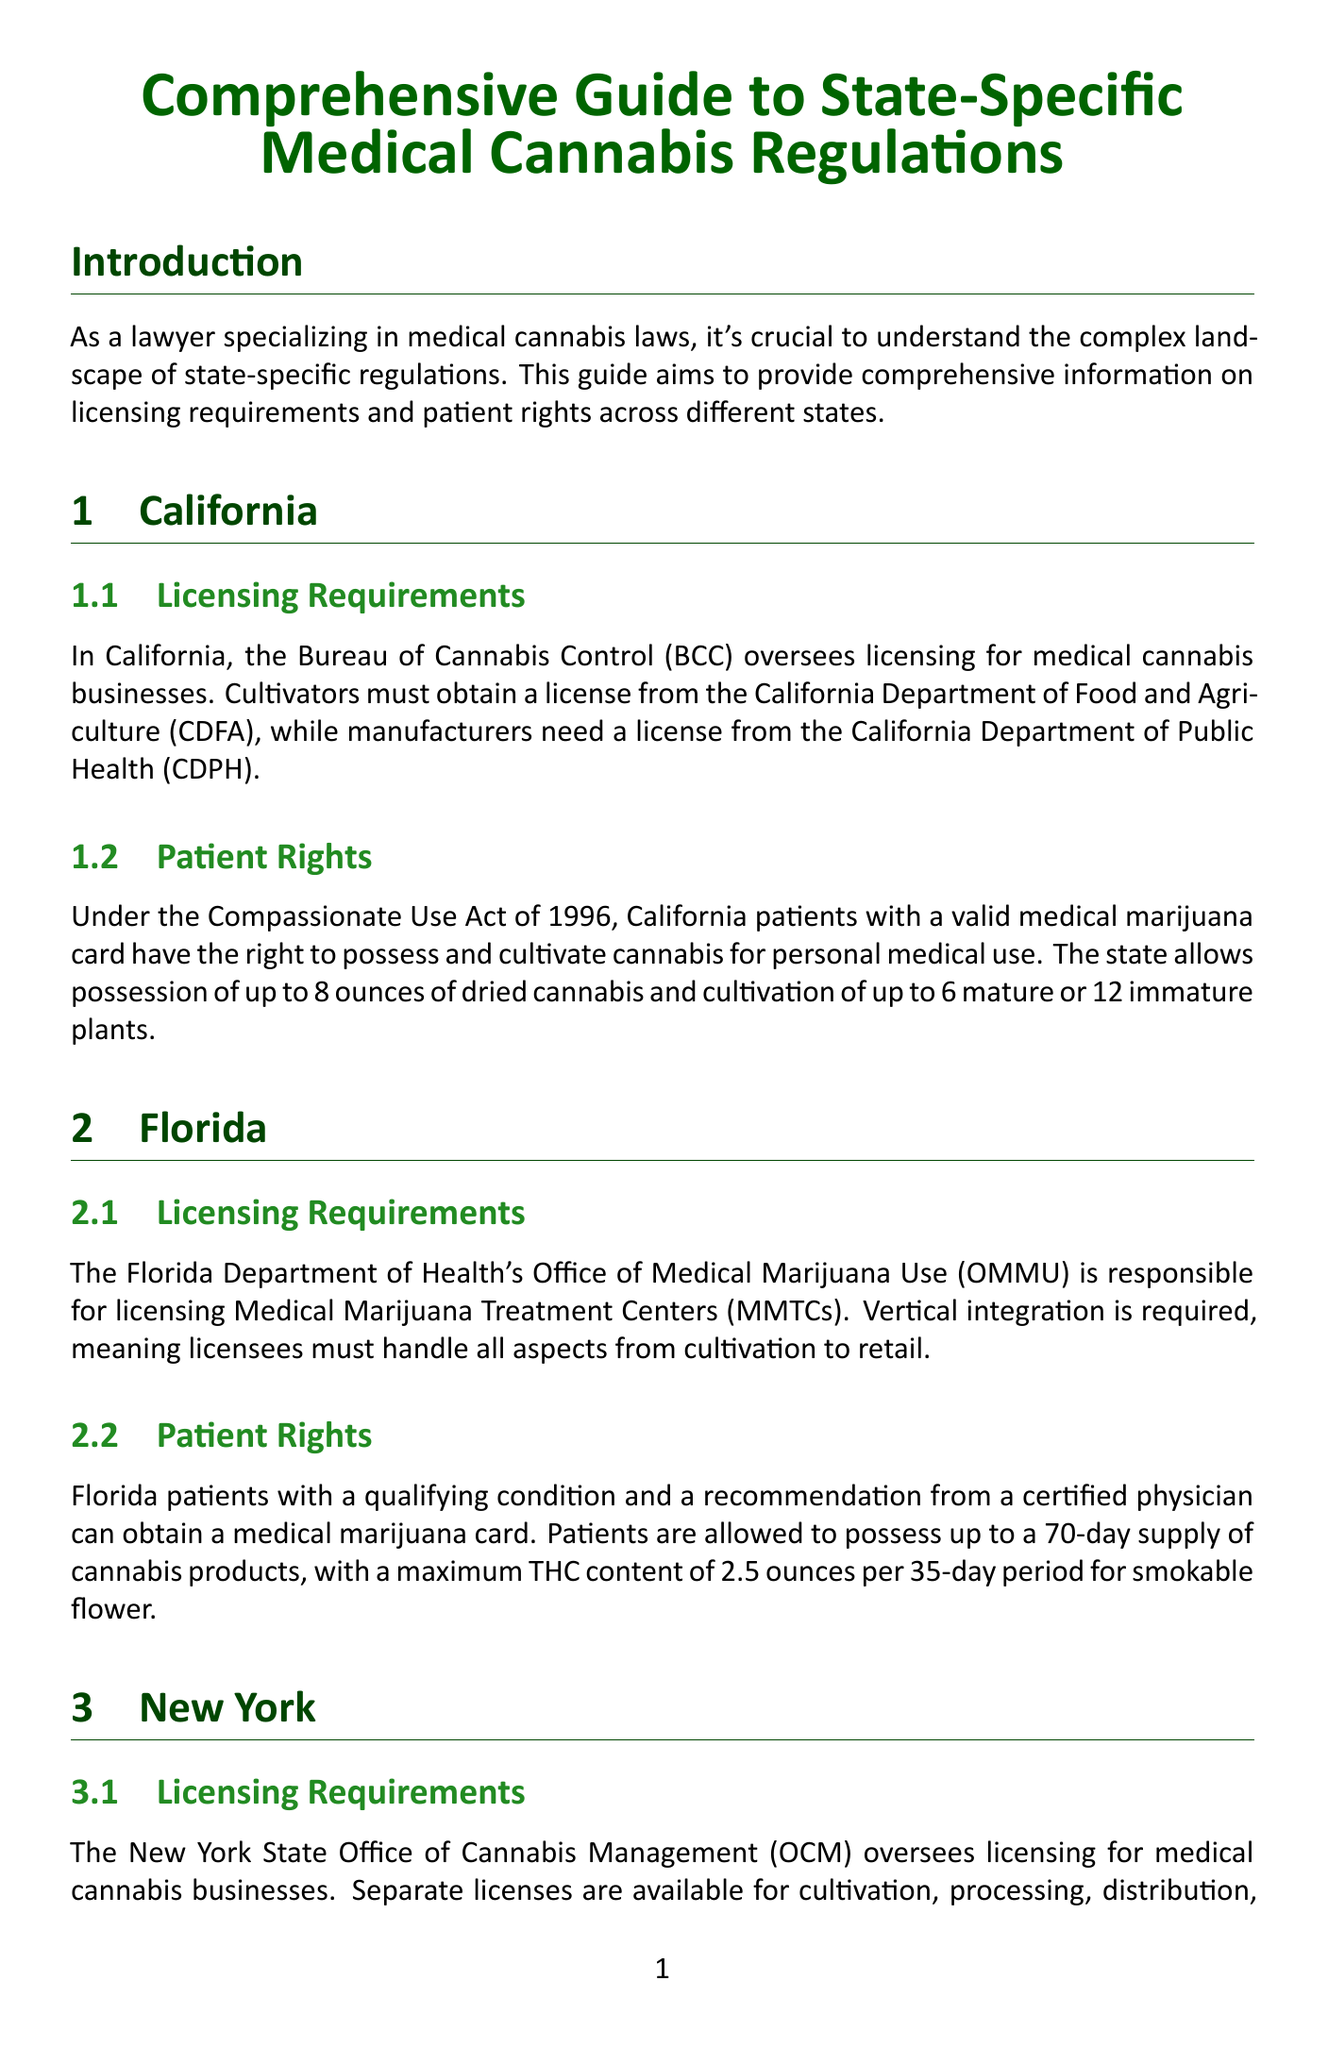What agency oversees licensing for medical cannabis businesses in California? The document states that the Bureau of Cannabis Control (BCC) oversees licensing for medical cannabis businesses in California.
Answer: Bureau of Cannabis Control (BCC) What is the maximum number of mature plants a patient can cultivate in California? According to the document, California allows patients to cultivate up to 6 mature plants for personal medical use.
Answer: 6 mature plants How many days' supply of cannabis products can Florida patients possess? The document mentions that Florida patients are allowed to possess up to a 70-day supply of cannabis products.
Answer: 70 days What is the required integration for Medical Marijuana Treatment Centers in Florida? The document states that vertical integration is required for Medical Marijuana Treatment Centers (MMTCs) in Florida.
Answer: Vertical integration How many plants can New York patients cultivate at home? The document specifies that New York patients can cultivate up to 6 plants (3 mature, 3 immature) at home.
Answer: 6 plants What law classifies cannabis as a Schedule I controlled substance federally? The document indicates that cannabis remains classified as a Schedule I controlled substance under federal law.
Answer: Schedule I What is a best practice for lawyers to ensure compliance with medical cannabis laws? The document lists staying updated on rapidly changing regulations as one of the best practices for compliance.
Answer: Stay updated What does HIPAA protect in relation to medical cannabis patients? The document states that HIPAA protects medical cannabis patient data.
Answer: Patient data What is prohibited under interstate commerce restrictions? The document clearly mentions that interstate commerce of cannabis products is strictly forbidden due to federal prohibition.
Answer: Interstate commerce 